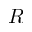Convert formula to latex. <formula><loc_0><loc_0><loc_500><loc_500>R</formula> 